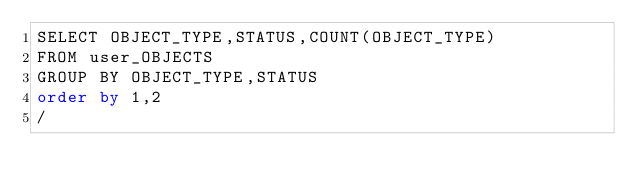<code> <loc_0><loc_0><loc_500><loc_500><_SQL_>SELECT OBJECT_TYPE,STATUS,COUNT(OBJECT_TYPE)
FROM user_OBJECTS
GROUP BY OBJECT_TYPE,STATUS
order by 1,2
/
</code> 